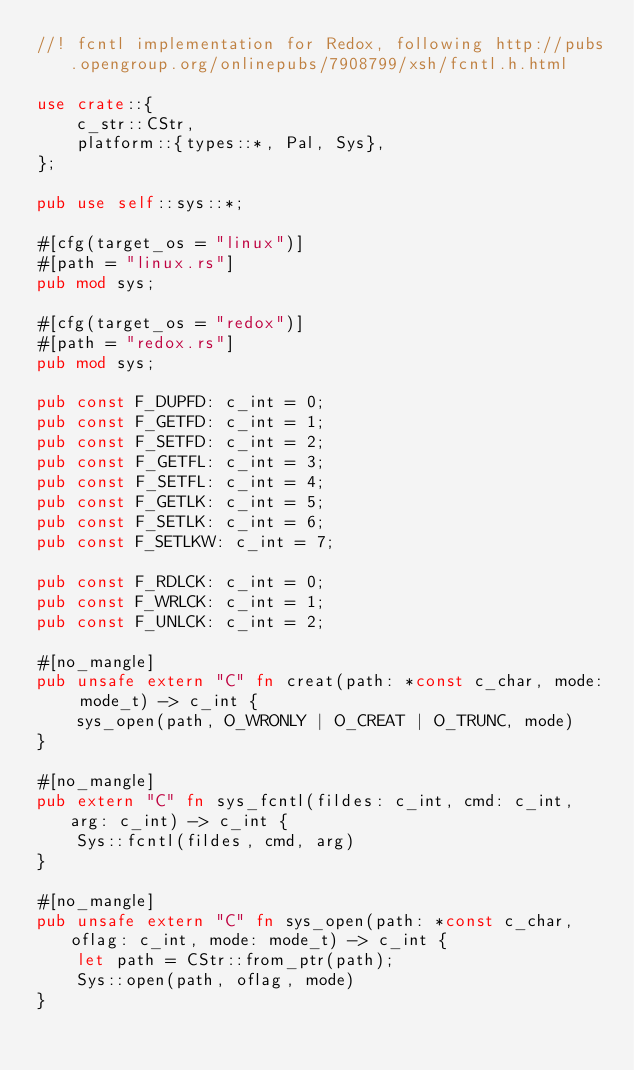<code> <loc_0><loc_0><loc_500><loc_500><_Rust_>//! fcntl implementation for Redox, following http://pubs.opengroup.org/onlinepubs/7908799/xsh/fcntl.h.html

use crate::{
    c_str::CStr,
    platform::{types::*, Pal, Sys},
};

pub use self::sys::*;

#[cfg(target_os = "linux")]
#[path = "linux.rs"]
pub mod sys;

#[cfg(target_os = "redox")]
#[path = "redox.rs"]
pub mod sys;

pub const F_DUPFD: c_int = 0;
pub const F_GETFD: c_int = 1;
pub const F_SETFD: c_int = 2;
pub const F_GETFL: c_int = 3;
pub const F_SETFL: c_int = 4;
pub const F_GETLK: c_int = 5;
pub const F_SETLK: c_int = 6;
pub const F_SETLKW: c_int = 7;

pub const F_RDLCK: c_int = 0;
pub const F_WRLCK: c_int = 1;
pub const F_UNLCK: c_int = 2;

#[no_mangle]
pub unsafe extern "C" fn creat(path: *const c_char, mode: mode_t) -> c_int {
    sys_open(path, O_WRONLY | O_CREAT | O_TRUNC, mode)
}

#[no_mangle]
pub extern "C" fn sys_fcntl(fildes: c_int, cmd: c_int, arg: c_int) -> c_int {
    Sys::fcntl(fildes, cmd, arg)
}

#[no_mangle]
pub unsafe extern "C" fn sys_open(path: *const c_char, oflag: c_int, mode: mode_t) -> c_int {
    let path = CStr::from_ptr(path);
    Sys::open(path, oflag, mode)
}
</code> 